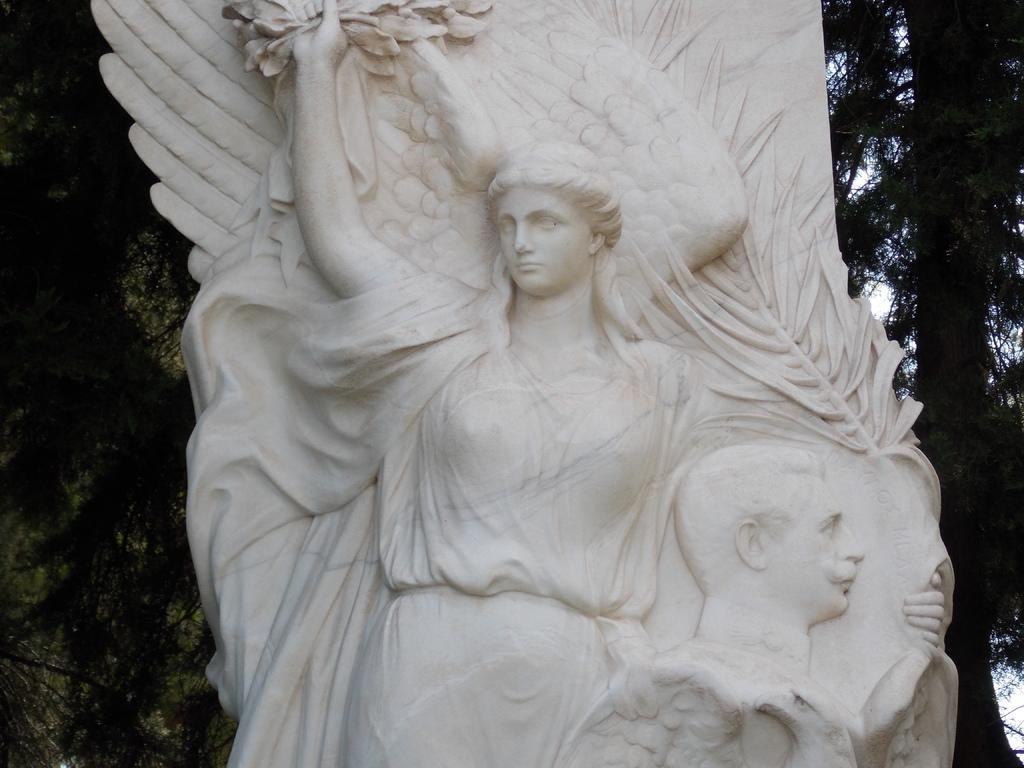What is the main subject in the image? There is a white color women statue in the image. What can be seen in the background of the image? There are trees in the background of the image. What type of treatment is the statue receiving in the image? There is no treatment being administered to the statue in the image. What is the statue holding in the image? The statue is not holding anything in the image, as it is a sculpture. 